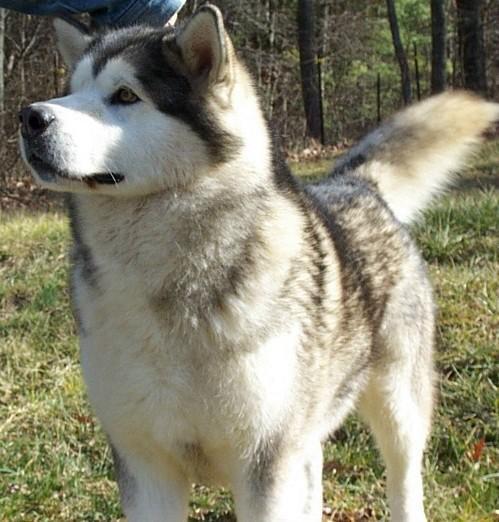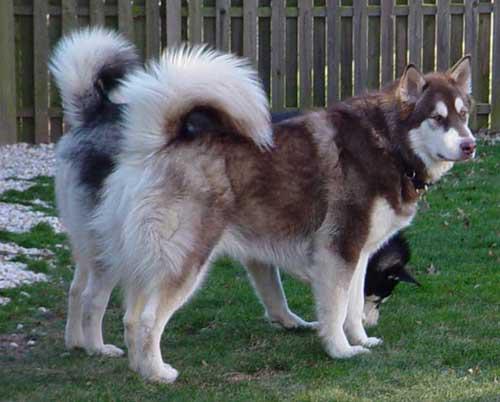The first image is the image on the left, the second image is the image on the right. Examine the images to the left and right. Is the description "There is a total of four dogs." accurate? Answer yes or no. No. The first image is the image on the left, the second image is the image on the right. Evaluate the accuracy of this statement regarding the images: "There are four dogs.". Is it true? Answer yes or no. No. 